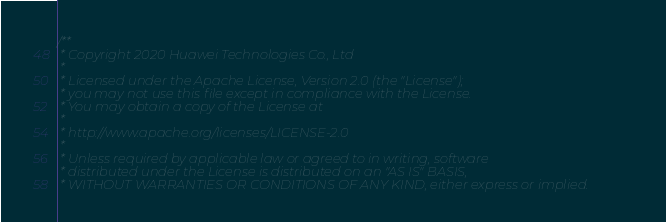Convert code to text. <code><loc_0><loc_0><loc_500><loc_500><_Cuda_>/**
 * Copyright 2020 Huawei Technologies Co., Ltd
 *
 * Licensed under the Apache License, Version 2.0 (the "License");
 * you may not use this file except in compliance with the License.
 * You may obtain a copy of the License at
 *
 * http://www.apache.org/licenses/LICENSE-2.0
 *
 * Unless required by applicable law or agreed to in writing, software
 * distributed under the License is distributed on an "AS IS" BASIS,
 * WITHOUT WARRANTIES OR CONDITIONS OF ANY KIND, either express or implied.</code> 